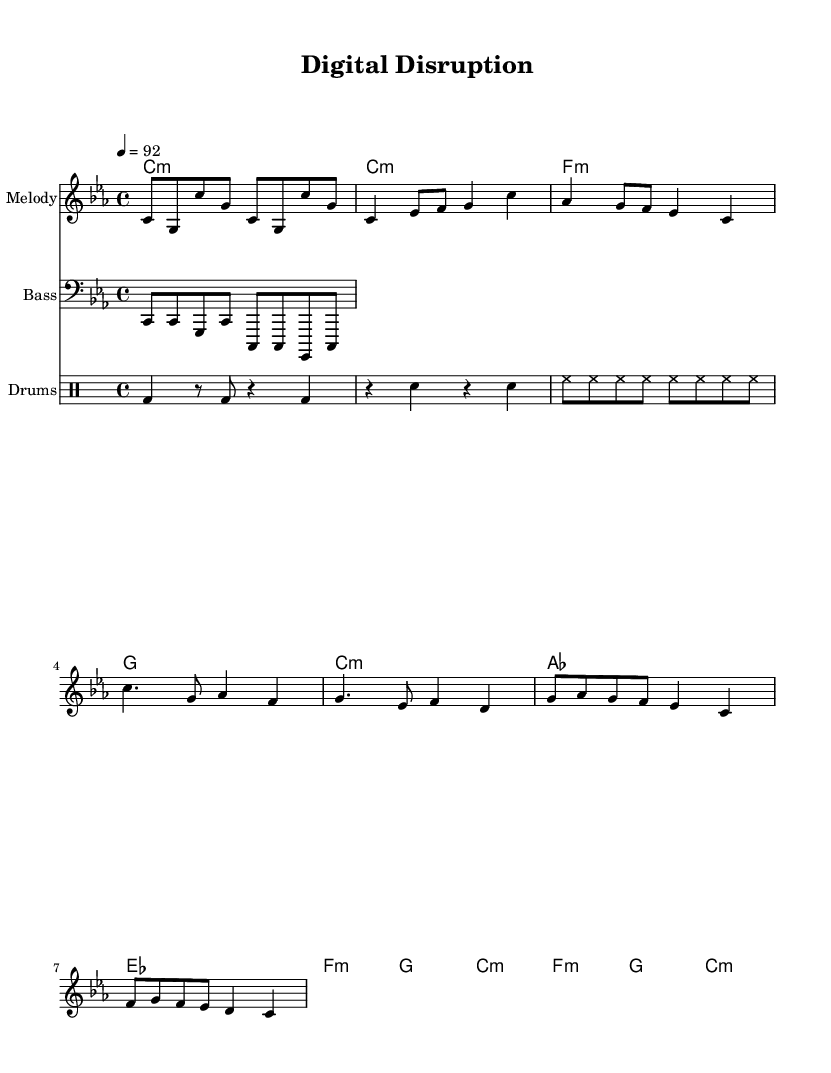what is the key signature of this music? The key signature indicates that the music is in C minor, which has three flats (B flat, E flat, and A flat). This can be identified in the key signature notation at the beginning of the staff.
Answer: C minor what is the time signature of this music? The time signature is found at the beginning of the score and indicates that there are four beats in each measure with a quarter note receiving one beat, which is typical in hip hop.
Answer: 4/4 what is the tempo marking of this music? The tempo marking indicates the speed of the piece, which is 92 beats per minute. This is reflected in the tempo indication found at the beginning of the score.
Answer: 92 how many measures are there in the verse section? The verse section is composed of two lines, each containing four measures, resulting in a total of eight measures in this section. Counting the bars listed confirms this structure.
Answer: 8 what type of instrument plays the melody? The melody is specifically designated to be played by a staff labeled "Melody," indicating that it is an instrument, likely a lead instrument or vocal line, which is common in hip hop music.
Answer: Melody what chord is played during the chorus? The chorus features the following chord progression: A flat major, E flat major, F minor, and G major; recognizing these chords labeled in the "ChordNames" staff leads to this conclusion.
Answer: A flat major, E flat major, F minor, G major how is the bass pattern structured? The bass pattern consists of eighth notes, playing C and G in a repetitive sequence, which is reflected in the bass staff notation. This repetition creates a foundational groove typical in hip hop tracks.
Answer: Repetitive eighth notes 